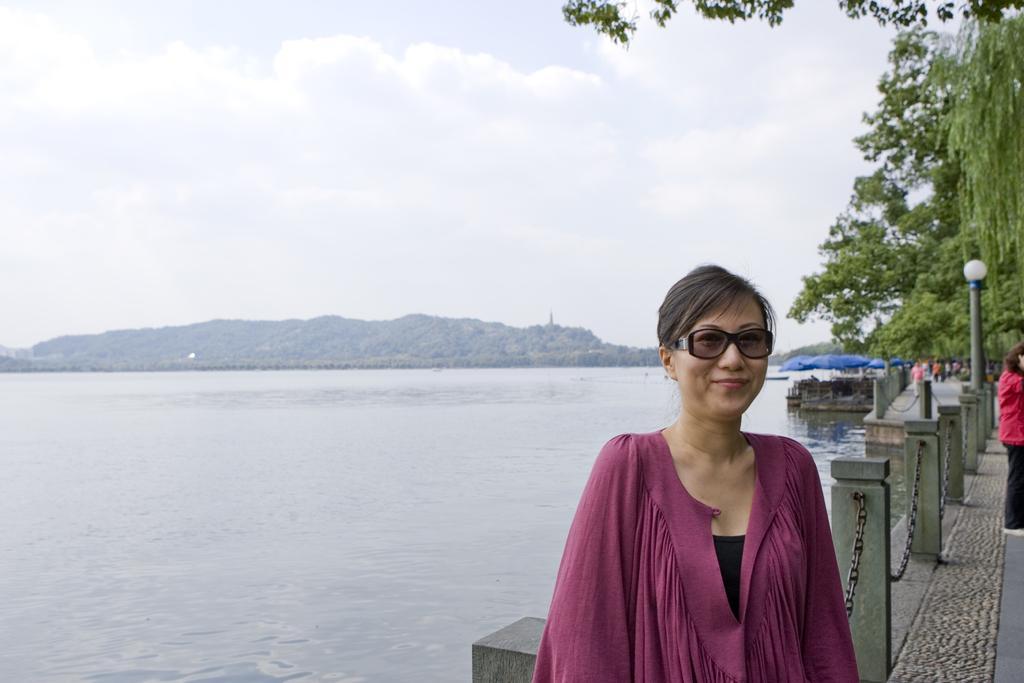How would you summarize this image in a sentence or two? In this image I see a woman who is smiling and I see that she is wearing pink color dress and wearing shades and I see the path, fencing, a light pole and I see a person over here. In the background I see the water, mountains, few more people over here and I see the sky. 